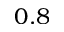<formula> <loc_0><loc_0><loc_500><loc_500>0 . 8</formula> 